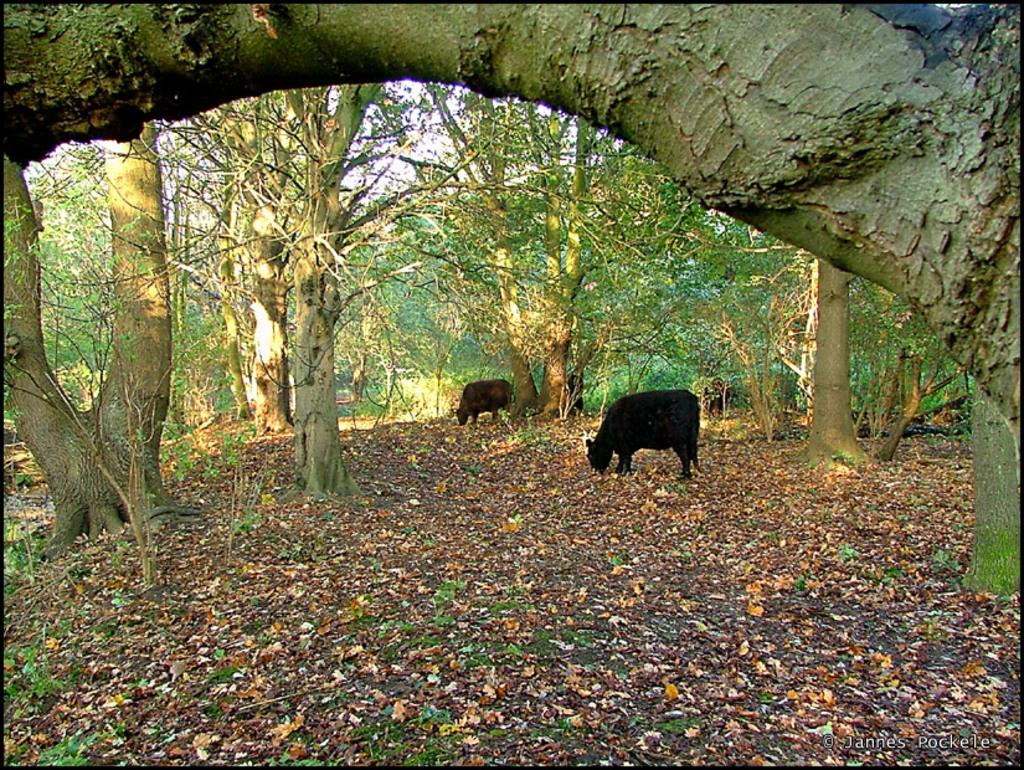What is present on the ground in the image? There are two animals on the ground in the image. What type of natural material can be seen in the image? Dry leaves are visible in the image. What can be seen in the background of the image? There are trees in the background of the image. How many books are being used to support the animals in the image? There are no books present in the image, and the animals are not being supported by any objects. 